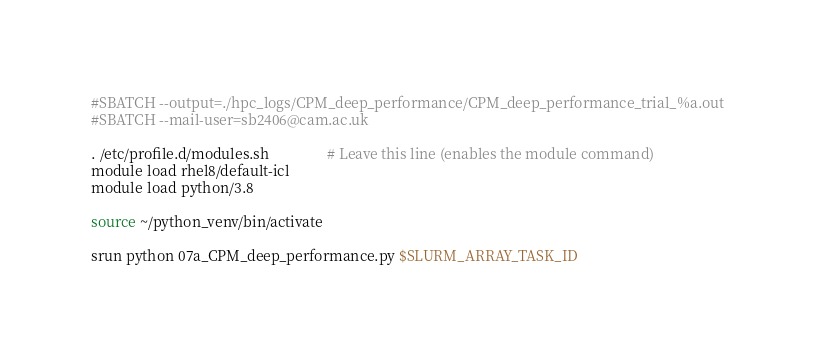<code> <loc_0><loc_0><loc_500><loc_500><_Bash_>#SBATCH --output=./hpc_logs/CPM_deep_performance/CPM_deep_performance_trial_%a.out
#SBATCH --mail-user=sb2406@cam.ac.uk

. /etc/profile.d/modules.sh                # Leave this line (enables the module command)
module load rhel8/default-icl
module load python/3.8

source ~/python_venv/bin/activate

srun python 07a_CPM_deep_performance.py $SLURM_ARRAY_TASK_ID</code> 